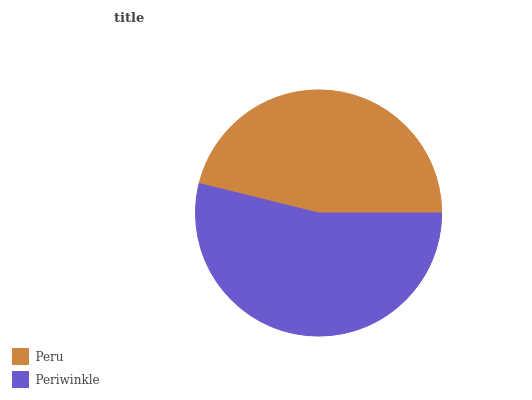Is Peru the minimum?
Answer yes or no. Yes. Is Periwinkle the maximum?
Answer yes or no. Yes. Is Periwinkle the minimum?
Answer yes or no. No. Is Periwinkle greater than Peru?
Answer yes or no. Yes. Is Peru less than Periwinkle?
Answer yes or no. Yes. Is Peru greater than Periwinkle?
Answer yes or no. No. Is Periwinkle less than Peru?
Answer yes or no. No. Is Periwinkle the high median?
Answer yes or no. Yes. Is Peru the low median?
Answer yes or no. Yes. Is Peru the high median?
Answer yes or no. No. Is Periwinkle the low median?
Answer yes or no. No. 